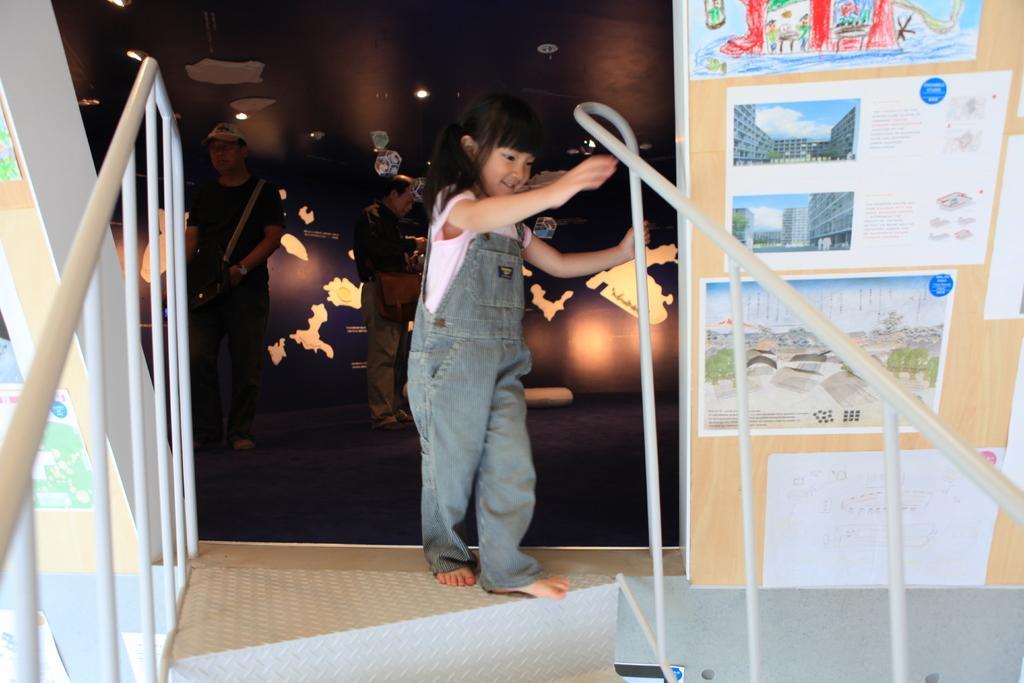Describe this image in one or two sentences. In this image, we can see a girl is holding a rod. Here we can see railings, posters, wall, few people and lights. 